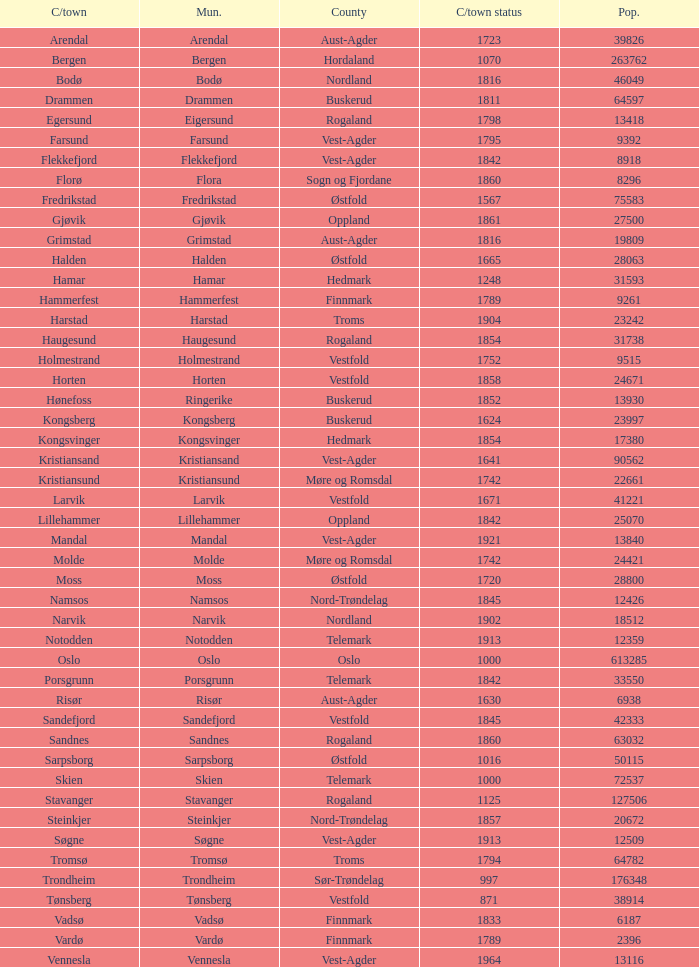In which county is the city/town of Halden located? Østfold. 